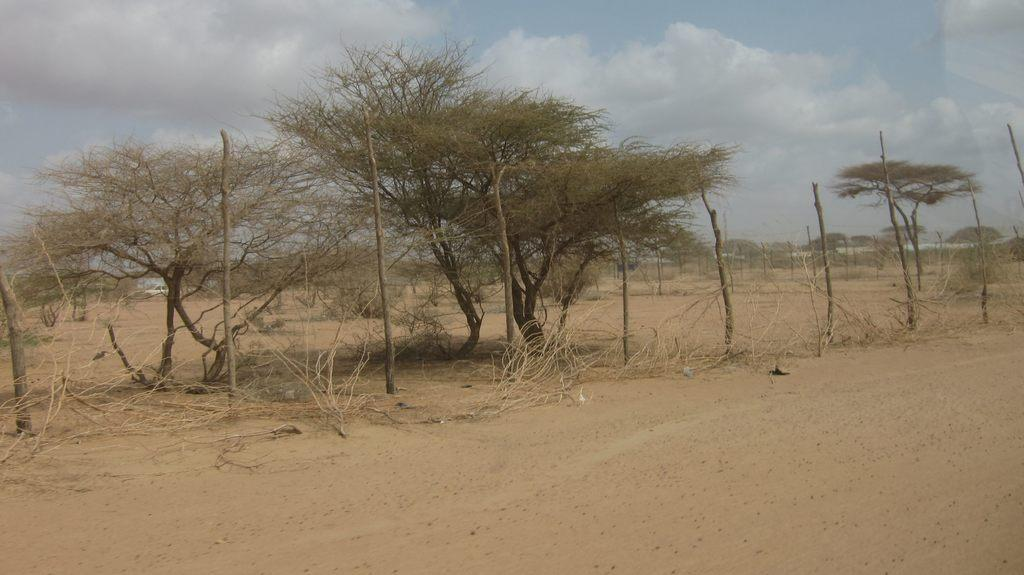What type of terrain is visible in the image? There is land visible in the image. What objects can be seen on the land? There are wooden sticks and trees on the land. How many dogs are interacting with the hydrant in the image? There are no dogs or hydrants present in the image. What type of trade is being conducted on the land in the image? There is no indication of any trade activity in the image. 